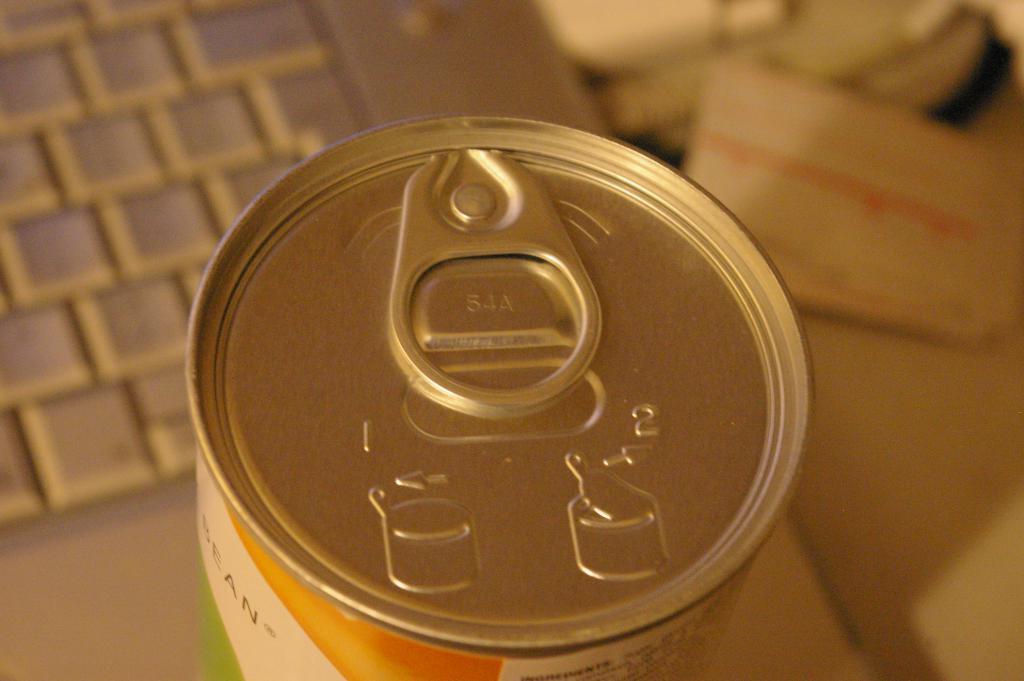Can you describe this image briefly? In this image I can see the tin and the keyboard. I can see the blurred background. 